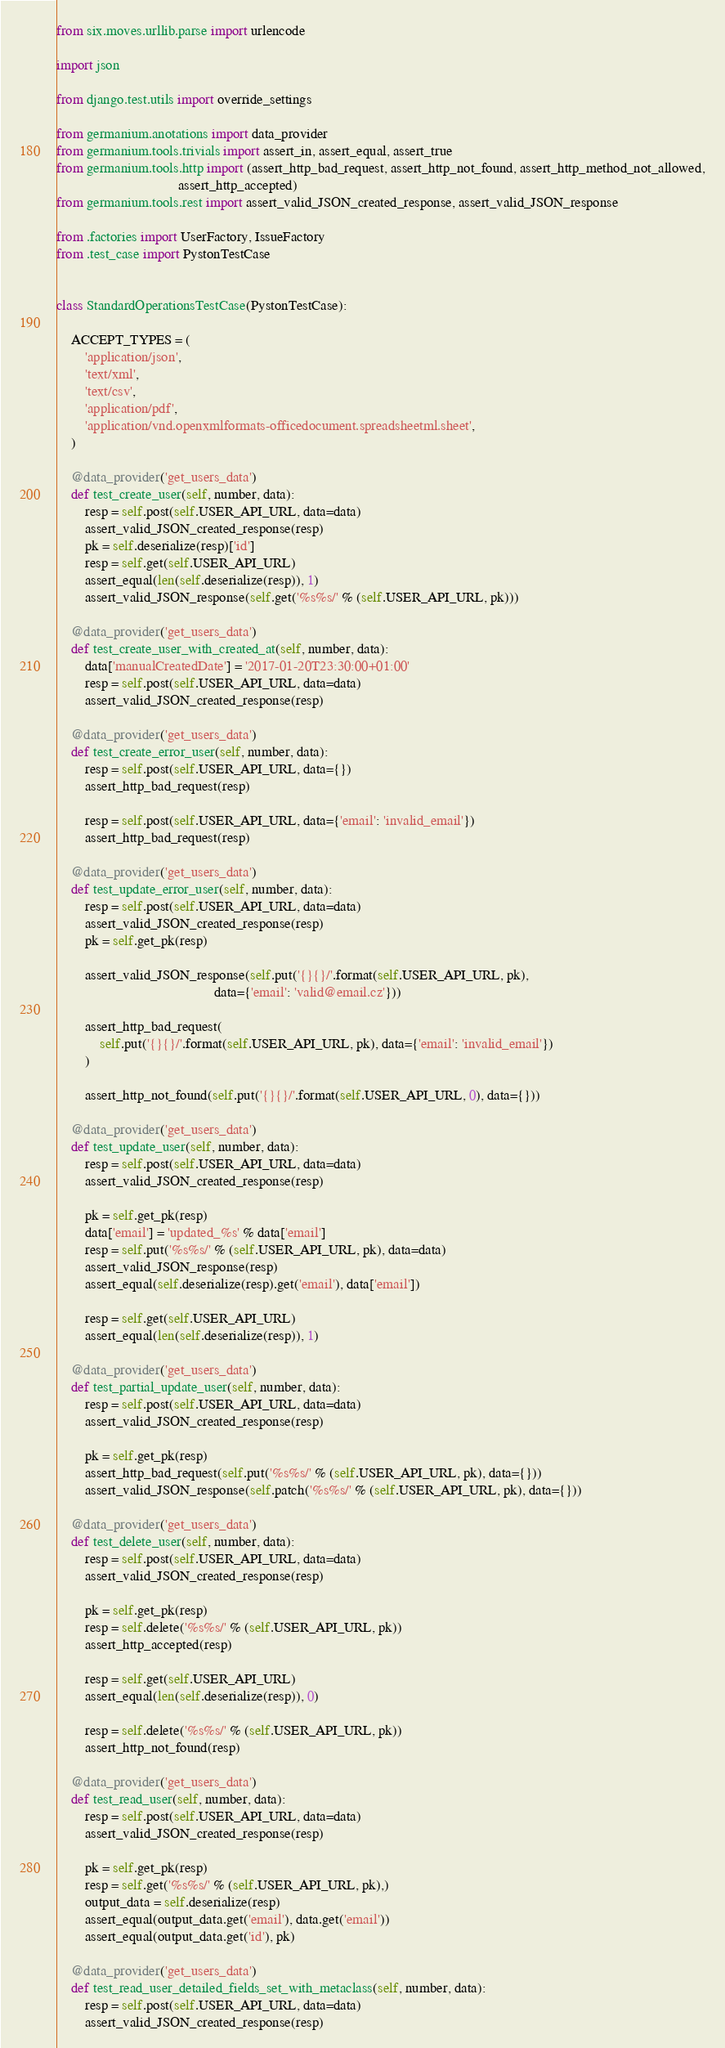<code> <loc_0><loc_0><loc_500><loc_500><_Python_>from six.moves.urllib.parse import urlencode

import json

from django.test.utils import override_settings

from germanium.anotations import data_provider
from germanium.tools.trivials import assert_in, assert_equal, assert_true
from germanium.tools.http import (assert_http_bad_request, assert_http_not_found, assert_http_method_not_allowed,
                                  assert_http_accepted)
from germanium.tools.rest import assert_valid_JSON_created_response, assert_valid_JSON_response

from .factories import UserFactory, IssueFactory
from .test_case import PystonTestCase


class StandardOperationsTestCase(PystonTestCase):

    ACCEPT_TYPES = (
        'application/json',
        'text/xml',
        'text/csv',
        'application/pdf',
        'application/vnd.openxmlformats-officedocument.spreadsheetml.sheet',
    )

    @data_provider('get_users_data')
    def test_create_user(self, number, data):
        resp = self.post(self.USER_API_URL, data=data)
        assert_valid_JSON_created_response(resp)
        pk = self.deserialize(resp)['id']
        resp = self.get(self.USER_API_URL)
        assert_equal(len(self.deserialize(resp)), 1)
        assert_valid_JSON_response(self.get('%s%s/' % (self.USER_API_URL, pk)))

    @data_provider('get_users_data')
    def test_create_user_with_created_at(self, number, data):
        data['manualCreatedDate'] = '2017-01-20T23:30:00+01:00'
        resp = self.post(self.USER_API_URL, data=data)
        assert_valid_JSON_created_response(resp)

    @data_provider('get_users_data')
    def test_create_error_user(self, number, data):
        resp = self.post(self.USER_API_URL, data={})
        assert_http_bad_request(resp)

        resp = self.post(self.USER_API_URL, data={'email': 'invalid_email'})
        assert_http_bad_request(resp)

    @data_provider('get_users_data')
    def test_update_error_user(self, number, data):
        resp = self.post(self.USER_API_URL, data=data)
        assert_valid_JSON_created_response(resp)
        pk = self.get_pk(resp)

        assert_valid_JSON_response(self.put('{}{}/'.format(self.USER_API_URL, pk),
                                            data={'email': 'valid@email.cz'}))

        assert_http_bad_request(
            self.put('{}{}/'.format(self.USER_API_URL, pk), data={'email': 'invalid_email'})
        )

        assert_http_not_found(self.put('{}{}/'.format(self.USER_API_URL, 0), data={}))

    @data_provider('get_users_data')
    def test_update_user(self, number, data):
        resp = self.post(self.USER_API_URL, data=data)
        assert_valid_JSON_created_response(resp)

        pk = self.get_pk(resp)
        data['email'] = 'updated_%s' % data['email']
        resp = self.put('%s%s/' % (self.USER_API_URL, pk), data=data)
        assert_valid_JSON_response(resp)
        assert_equal(self.deserialize(resp).get('email'), data['email'])

        resp = self.get(self.USER_API_URL)
        assert_equal(len(self.deserialize(resp)), 1)

    @data_provider('get_users_data')
    def test_partial_update_user(self, number, data):
        resp = self.post(self.USER_API_URL, data=data)
        assert_valid_JSON_created_response(resp)

        pk = self.get_pk(resp)
        assert_http_bad_request(self.put('%s%s/' % (self.USER_API_URL, pk), data={}))
        assert_valid_JSON_response(self.patch('%s%s/' % (self.USER_API_URL, pk), data={}))

    @data_provider('get_users_data')
    def test_delete_user(self, number, data):
        resp = self.post(self.USER_API_URL, data=data)
        assert_valid_JSON_created_response(resp)

        pk = self.get_pk(resp)
        resp = self.delete('%s%s/' % (self.USER_API_URL, pk))
        assert_http_accepted(resp)

        resp = self.get(self.USER_API_URL)
        assert_equal(len(self.deserialize(resp)), 0)

        resp = self.delete('%s%s/' % (self.USER_API_URL, pk))
        assert_http_not_found(resp)

    @data_provider('get_users_data')
    def test_read_user(self, number, data):
        resp = self.post(self.USER_API_URL, data=data)
        assert_valid_JSON_created_response(resp)

        pk = self.get_pk(resp)
        resp = self.get('%s%s/' % (self.USER_API_URL, pk),)
        output_data = self.deserialize(resp)
        assert_equal(output_data.get('email'), data.get('email'))
        assert_equal(output_data.get('id'), pk)

    @data_provider('get_users_data')
    def test_read_user_detailed_fields_set_with_metaclass(self, number, data):
        resp = self.post(self.USER_API_URL, data=data)
        assert_valid_JSON_created_response(resp)
</code> 